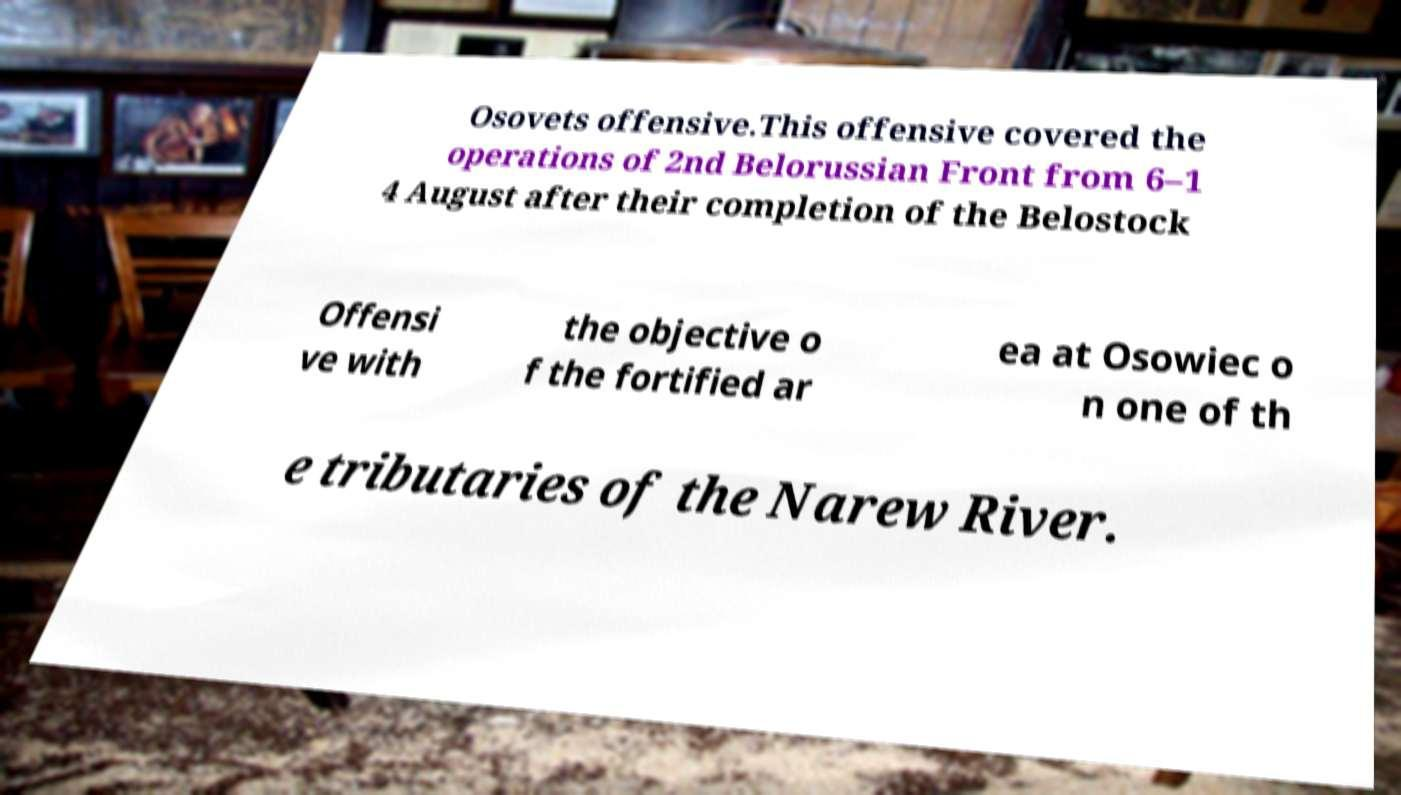There's text embedded in this image that I need extracted. Can you transcribe it verbatim? Osovets offensive.This offensive covered the operations of 2nd Belorussian Front from 6–1 4 August after their completion of the Belostock Offensi ve with the objective o f the fortified ar ea at Osowiec o n one of th e tributaries of the Narew River. 